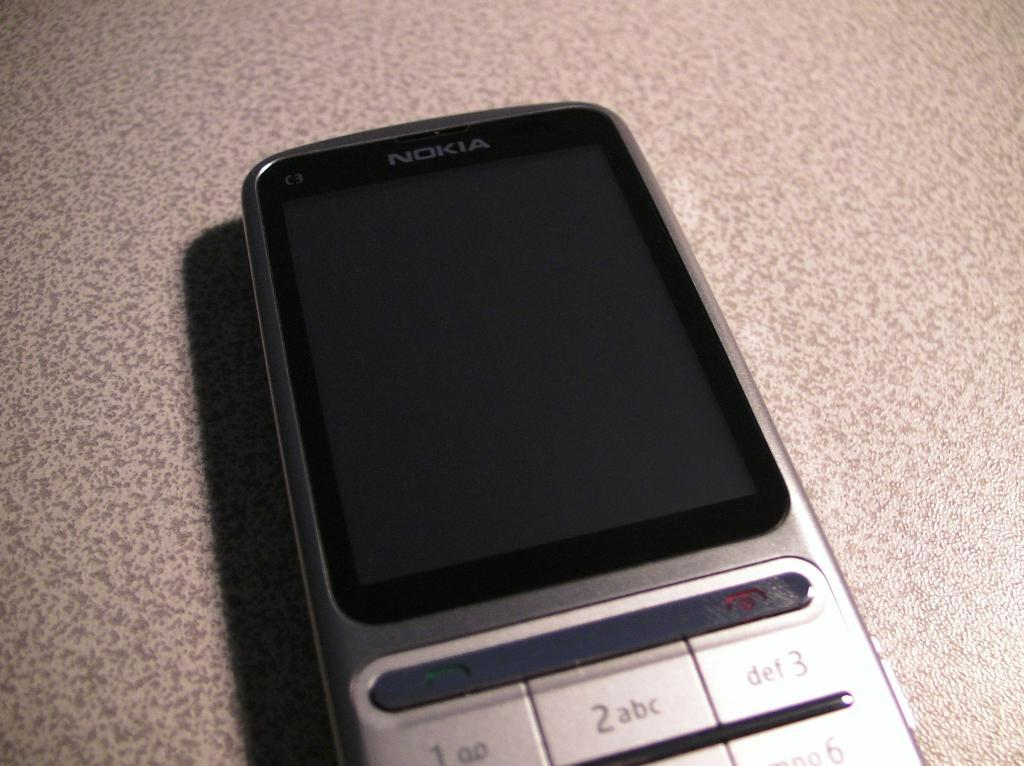<image>
Relay a brief, clear account of the picture shown. An old phone by Nokia sits with the screen off. 